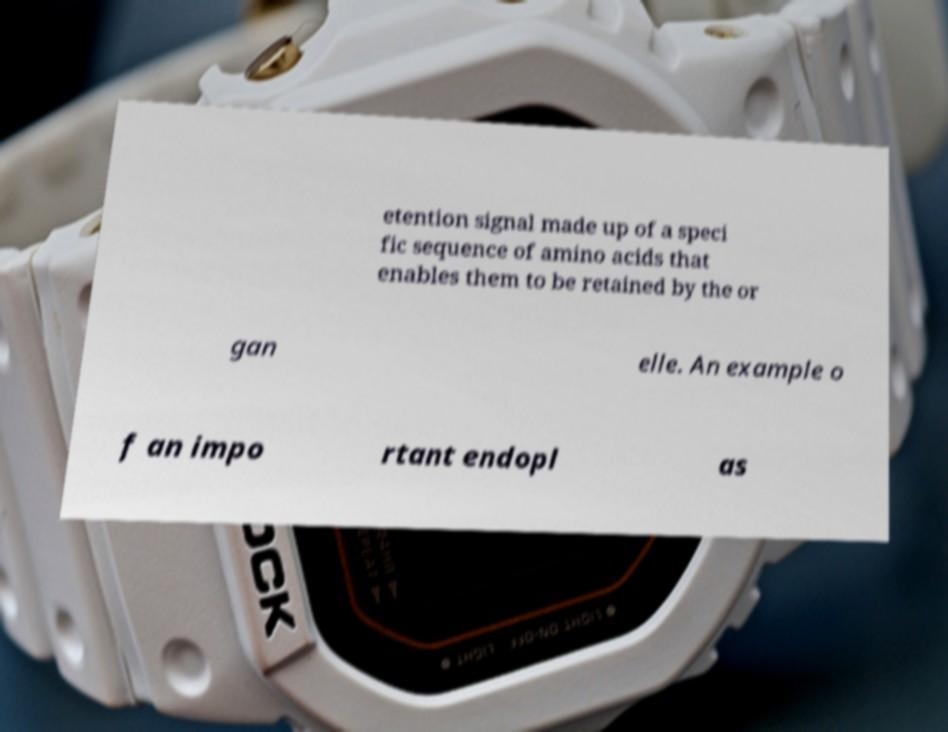What messages or text are displayed in this image? I need them in a readable, typed format. etention signal made up of a speci fic sequence of amino acids that enables them to be retained by the or gan elle. An example o f an impo rtant endopl as 